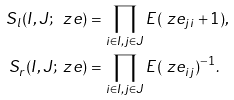<formula> <loc_0><loc_0><loc_500><loc_500>S _ { l } ( I , J ; \ z e ) & = \prod _ { i \in I , j \in J } E ( \ z e _ { j i } + 1 ) , \\ S _ { r } ( I , J ; \ z e ) & = \prod _ { i \in I , j \in J } E ( \ z e _ { i j } ) ^ { - 1 } .</formula> 